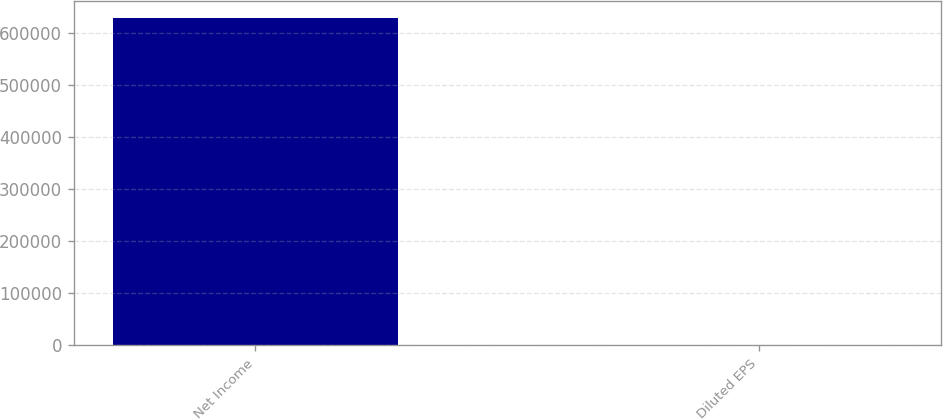Convert chart to OTSL. <chart><loc_0><loc_0><loc_500><loc_500><bar_chart><fcel>Net Income<fcel>Diluted EPS<nl><fcel>629320<fcel>1.98<nl></chart> 